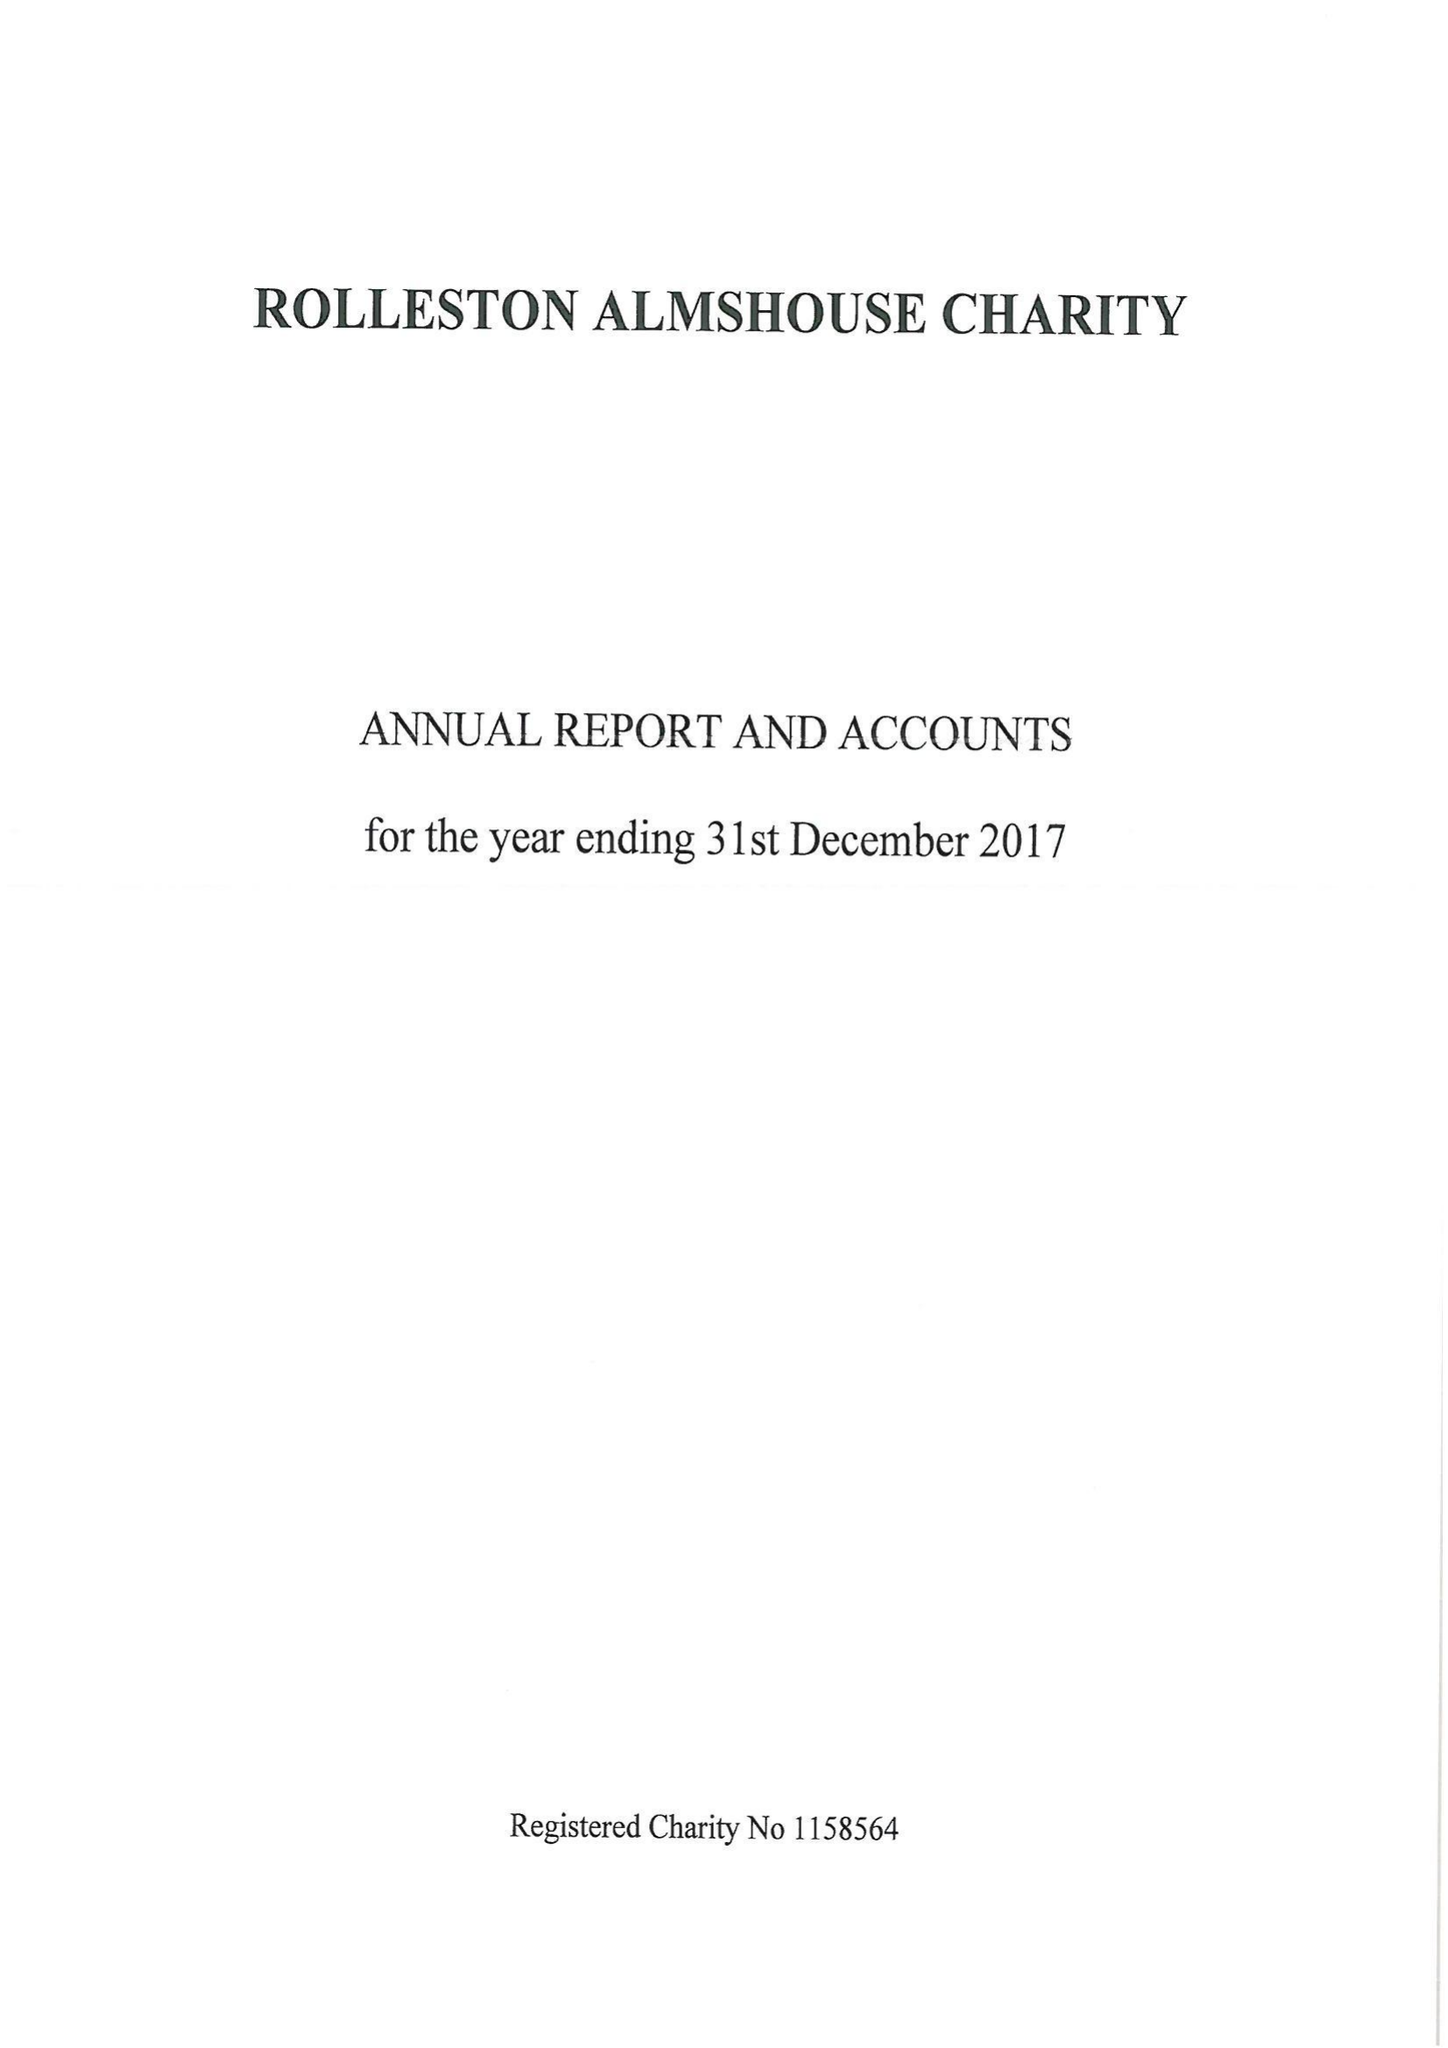What is the value for the charity_number?
Answer the question using a single word or phrase. 1158564 